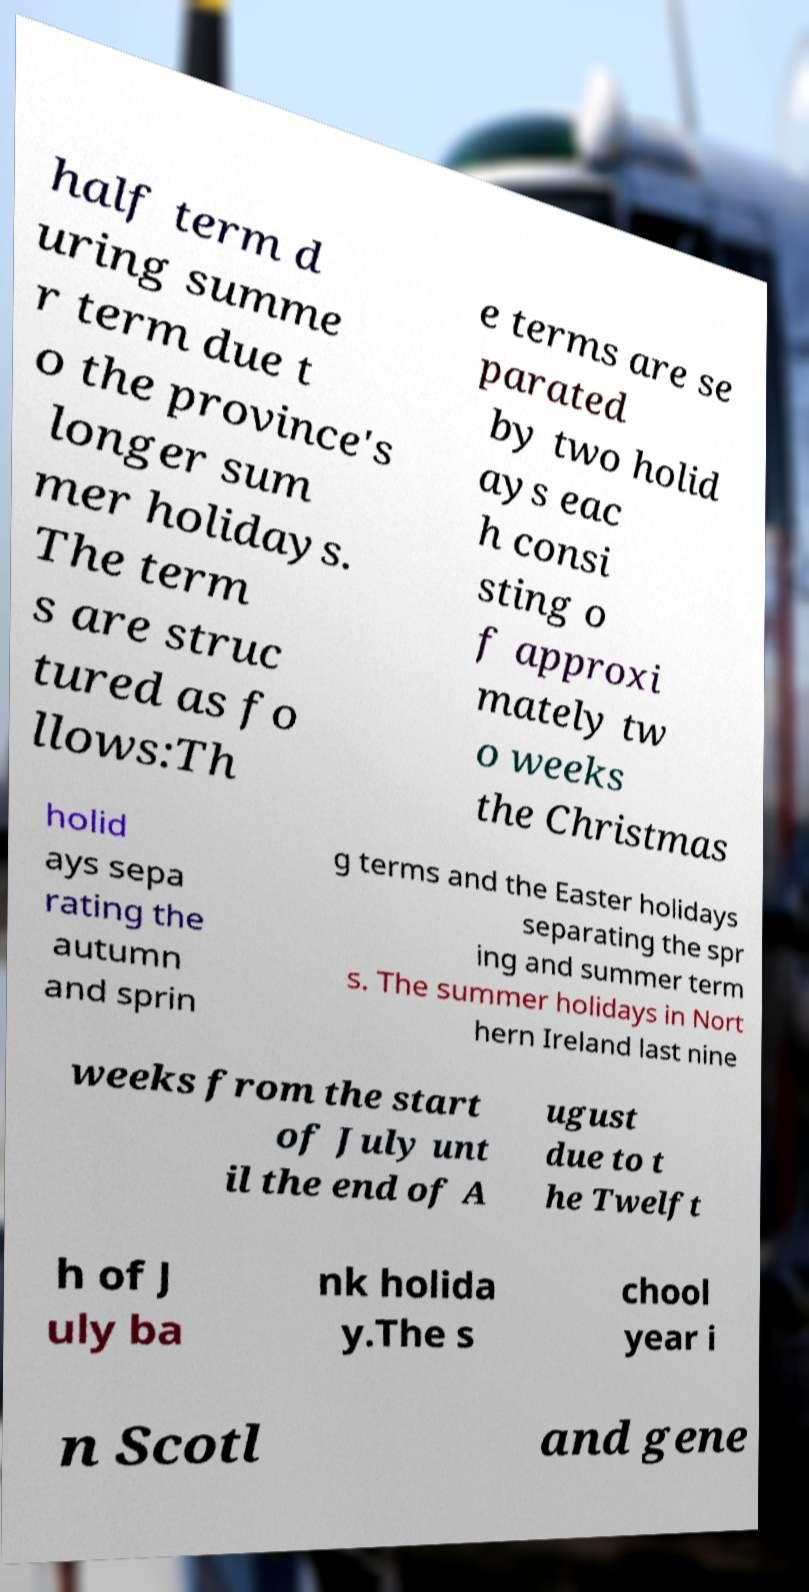Can you read and provide the text displayed in the image?This photo seems to have some interesting text. Can you extract and type it out for me? half term d uring summe r term due t o the province's longer sum mer holidays. The term s are struc tured as fo llows:Th e terms are se parated by two holid ays eac h consi sting o f approxi mately tw o weeks the Christmas holid ays sepa rating the autumn and sprin g terms and the Easter holidays separating the spr ing and summer term s. The summer holidays in Nort hern Ireland last nine weeks from the start of July unt il the end of A ugust due to t he Twelft h of J uly ba nk holida y.The s chool year i n Scotl and gene 